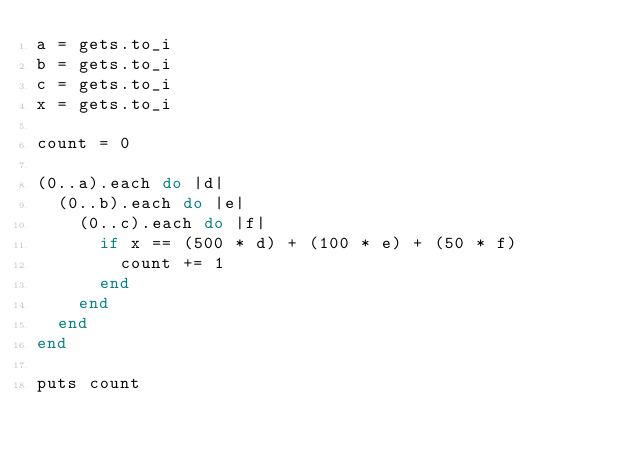<code> <loc_0><loc_0><loc_500><loc_500><_Ruby_>a = gets.to_i
b = gets.to_i
c = gets.to_i
x = gets.to_i

count = 0

(0..a).each do |d|
  (0..b).each do |e|
    (0..c).each do |f|
      if x == (500 * d) + (100 * e) + (50 * f)
        count += 1
      end
    end
  end
end

puts count</code> 